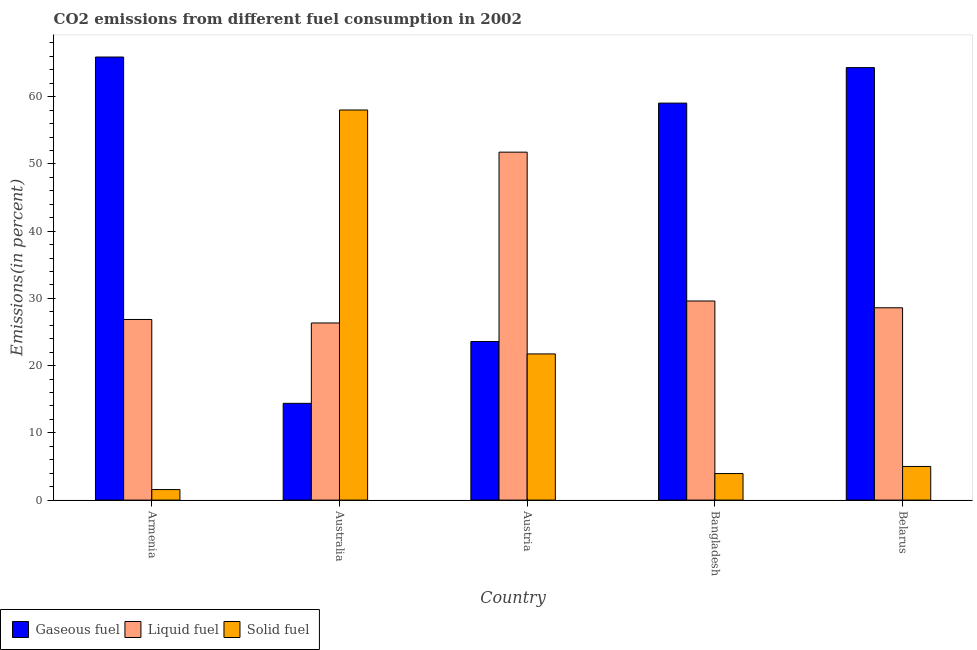How many different coloured bars are there?
Offer a terse response. 3. How many bars are there on the 1st tick from the right?
Offer a very short reply. 3. What is the percentage of liquid fuel emission in Armenia?
Ensure brevity in your answer.  26.87. Across all countries, what is the maximum percentage of gaseous fuel emission?
Ensure brevity in your answer.  65.9. Across all countries, what is the minimum percentage of gaseous fuel emission?
Your answer should be compact. 14.39. In which country was the percentage of liquid fuel emission maximum?
Your response must be concise. Austria. What is the total percentage of solid fuel emission in the graph?
Offer a terse response. 90.29. What is the difference between the percentage of liquid fuel emission in Armenia and that in Australia?
Offer a terse response. 0.52. What is the difference between the percentage of liquid fuel emission in Australia and the percentage of gaseous fuel emission in Bangladesh?
Your response must be concise. -32.7. What is the average percentage of solid fuel emission per country?
Provide a short and direct response. 18.06. What is the difference between the percentage of liquid fuel emission and percentage of solid fuel emission in Armenia?
Make the answer very short. 25.3. In how many countries, is the percentage of liquid fuel emission greater than 20 %?
Provide a succinct answer. 5. What is the ratio of the percentage of solid fuel emission in Australia to that in Austria?
Your response must be concise. 2.67. Is the percentage of solid fuel emission in Armenia less than that in Belarus?
Your answer should be compact. Yes. What is the difference between the highest and the second highest percentage of gaseous fuel emission?
Give a very brief answer. 1.57. What is the difference between the highest and the lowest percentage of solid fuel emission?
Offer a terse response. 56.46. What does the 3rd bar from the left in Austria represents?
Ensure brevity in your answer.  Solid fuel. What does the 1st bar from the right in Australia represents?
Keep it short and to the point. Solid fuel. Is it the case that in every country, the sum of the percentage of gaseous fuel emission and percentage of liquid fuel emission is greater than the percentage of solid fuel emission?
Offer a terse response. No. How many bars are there?
Your response must be concise. 15. Are all the bars in the graph horizontal?
Offer a terse response. No. What is the difference between two consecutive major ticks on the Y-axis?
Provide a succinct answer. 10. Are the values on the major ticks of Y-axis written in scientific E-notation?
Your response must be concise. No. Does the graph contain any zero values?
Make the answer very short. No. Does the graph contain grids?
Give a very brief answer. No. Where does the legend appear in the graph?
Ensure brevity in your answer.  Bottom left. How are the legend labels stacked?
Your response must be concise. Horizontal. What is the title of the graph?
Offer a very short reply. CO2 emissions from different fuel consumption in 2002. Does "Ages 20-60" appear as one of the legend labels in the graph?
Keep it short and to the point. No. What is the label or title of the Y-axis?
Give a very brief answer. Emissions(in percent). What is the Emissions(in percent) of Gaseous fuel in Armenia?
Provide a short and direct response. 65.9. What is the Emissions(in percent) in Liquid fuel in Armenia?
Your response must be concise. 26.87. What is the Emissions(in percent) in Solid fuel in Armenia?
Your response must be concise. 1.57. What is the Emissions(in percent) in Gaseous fuel in Australia?
Make the answer very short. 14.39. What is the Emissions(in percent) of Liquid fuel in Australia?
Provide a succinct answer. 26.35. What is the Emissions(in percent) of Solid fuel in Australia?
Offer a very short reply. 58.03. What is the Emissions(in percent) in Gaseous fuel in Austria?
Offer a terse response. 23.59. What is the Emissions(in percent) of Liquid fuel in Austria?
Make the answer very short. 51.75. What is the Emissions(in percent) in Solid fuel in Austria?
Provide a succinct answer. 21.74. What is the Emissions(in percent) of Gaseous fuel in Bangladesh?
Make the answer very short. 59.05. What is the Emissions(in percent) in Liquid fuel in Bangladesh?
Make the answer very short. 29.61. What is the Emissions(in percent) of Solid fuel in Bangladesh?
Your response must be concise. 3.95. What is the Emissions(in percent) in Gaseous fuel in Belarus?
Provide a short and direct response. 64.33. What is the Emissions(in percent) in Liquid fuel in Belarus?
Keep it short and to the point. 28.61. What is the Emissions(in percent) in Solid fuel in Belarus?
Provide a short and direct response. 5. Across all countries, what is the maximum Emissions(in percent) in Gaseous fuel?
Your answer should be very brief. 65.9. Across all countries, what is the maximum Emissions(in percent) in Liquid fuel?
Offer a very short reply. 51.75. Across all countries, what is the maximum Emissions(in percent) in Solid fuel?
Your answer should be very brief. 58.03. Across all countries, what is the minimum Emissions(in percent) in Gaseous fuel?
Give a very brief answer. 14.39. Across all countries, what is the minimum Emissions(in percent) of Liquid fuel?
Provide a succinct answer. 26.35. Across all countries, what is the minimum Emissions(in percent) of Solid fuel?
Give a very brief answer. 1.57. What is the total Emissions(in percent) of Gaseous fuel in the graph?
Provide a short and direct response. 227.26. What is the total Emissions(in percent) of Liquid fuel in the graph?
Offer a terse response. 163.19. What is the total Emissions(in percent) in Solid fuel in the graph?
Keep it short and to the point. 90.29. What is the difference between the Emissions(in percent) of Gaseous fuel in Armenia and that in Australia?
Your answer should be compact. 51.51. What is the difference between the Emissions(in percent) of Liquid fuel in Armenia and that in Australia?
Your answer should be compact. 0.52. What is the difference between the Emissions(in percent) in Solid fuel in Armenia and that in Australia?
Your answer should be compact. -56.46. What is the difference between the Emissions(in percent) of Gaseous fuel in Armenia and that in Austria?
Give a very brief answer. 42.32. What is the difference between the Emissions(in percent) in Liquid fuel in Armenia and that in Austria?
Keep it short and to the point. -24.89. What is the difference between the Emissions(in percent) in Solid fuel in Armenia and that in Austria?
Make the answer very short. -20.17. What is the difference between the Emissions(in percent) in Gaseous fuel in Armenia and that in Bangladesh?
Give a very brief answer. 6.85. What is the difference between the Emissions(in percent) of Liquid fuel in Armenia and that in Bangladesh?
Give a very brief answer. -2.75. What is the difference between the Emissions(in percent) of Solid fuel in Armenia and that in Bangladesh?
Provide a succinct answer. -2.38. What is the difference between the Emissions(in percent) in Gaseous fuel in Armenia and that in Belarus?
Your answer should be compact. 1.57. What is the difference between the Emissions(in percent) in Liquid fuel in Armenia and that in Belarus?
Make the answer very short. -1.74. What is the difference between the Emissions(in percent) of Solid fuel in Armenia and that in Belarus?
Your answer should be very brief. -3.44. What is the difference between the Emissions(in percent) in Gaseous fuel in Australia and that in Austria?
Provide a short and direct response. -9.19. What is the difference between the Emissions(in percent) of Liquid fuel in Australia and that in Austria?
Offer a very short reply. -25.41. What is the difference between the Emissions(in percent) of Solid fuel in Australia and that in Austria?
Provide a short and direct response. 36.28. What is the difference between the Emissions(in percent) in Gaseous fuel in Australia and that in Bangladesh?
Ensure brevity in your answer.  -44.66. What is the difference between the Emissions(in percent) in Liquid fuel in Australia and that in Bangladesh?
Offer a terse response. -3.27. What is the difference between the Emissions(in percent) in Solid fuel in Australia and that in Bangladesh?
Your answer should be very brief. 54.08. What is the difference between the Emissions(in percent) in Gaseous fuel in Australia and that in Belarus?
Your answer should be very brief. -49.94. What is the difference between the Emissions(in percent) in Liquid fuel in Australia and that in Belarus?
Make the answer very short. -2.26. What is the difference between the Emissions(in percent) of Solid fuel in Australia and that in Belarus?
Offer a terse response. 53.02. What is the difference between the Emissions(in percent) of Gaseous fuel in Austria and that in Bangladesh?
Offer a very short reply. -35.47. What is the difference between the Emissions(in percent) in Liquid fuel in Austria and that in Bangladesh?
Your answer should be compact. 22.14. What is the difference between the Emissions(in percent) of Solid fuel in Austria and that in Bangladesh?
Your response must be concise. 17.79. What is the difference between the Emissions(in percent) in Gaseous fuel in Austria and that in Belarus?
Your answer should be very brief. -40.75. What is the difference between the Emissions(in percent) of Liquid fuel in Austria and that in Belarus?
Provide a short and direct response. 23.15. What is the difference between the Emissions(in percent) in Solid fuel in Austria and that in Belarus?
Your answer should be compact. 16.74. What is the difference between the Emissions(in percent) in Gaseous fuel in Bangladesh and that in Belarus?
Your response must be concise. -5.28. What is the difference between the Emissions(in percent) of Liquid fuel in Bangladesh and that in Belarus?
Provide a short and direct response. 1.01. What is the difference between the Emissions(in percent) of Solid fuel in Bangladesh and that in Belarus?
Your answer should be very brief. -1.06. What is the difference between the Emissions(in percent) in Gaseous fuel in Armenia and the Emissions(in percent) in Liquid fuel in Australia?
Offer a very short reply. 39.56. What is the difference between the Emissions(in percent) in Gaseous fuel in Armenia and the Emissions(in percent) in Solid fuel in Australia?
Offer a very short reply. 7.88. What is the difference between the Emissions(in percent) in Liquid fuel in Armenia and the Emissions(in percent) in Solid fuel in Australia?
Provide a short and direct response. -31.16. What is the difference between the Emissions(in percent) in Gaseous fuel in Armenia and the Emissions(in percent) in Liquid fuel in Austria?
Your answer should be compact. 14.15. What is the difference between the Emissions(in percent) of Gaseous fuel in Armenia and the Emissions(in percent) of Solid fuel in Austria?
Your answer should be very brief. 44.16. What is the difference between the Emissions(in percent) in Liquid fuel in Armenia and the Emissions(in percent) in Solid fuel in Austria?
Provide a succinct answer. 5.13. What is the difference between the Emissions(in percent) in Gaseous fuel in Armenia and the Emissions(in percent) in Liquid fuel in Bangladesh?
Your response must be concise. 36.29. What is the difference between the Emissions(in percent) in Gaseous fuel in Armenia and the Emissions(in percent) in Solid fuel in Bangladesh?
Your response must be concise. 61.95. What is the difference between the Emissions(in percent) of Liquid fuel in Armenia and the Emissions(in percent) of Solid fuel in Bangladesh?
Offer a terse response. 22.92. What is the difference between the Emissions(in percent) in Gaseous fuel in Armenia and the Emissions(in percent) in Liquid fuel in Belarus?
Keep it short and to the point. 37.3. What is the difference between the Emissions(in percent) in Gaseous fuel in Armenia and the Emissions(in percent) in Solid fuel in Belarus?
Provide a succinct answer. 60.9. What is the difference between the Emissions(in percent) in Liquid fuel in Armenia and the Emissions(in percent) in Solid fuel in Belarus?
Your response must be concise. 21.86. What is the difference between the Emissions(in percent) in Gaseous fuel in Australia and the Emissions(in percent) in Liquid fuel in Austria?
Your answer should be compact. -37.36. What is the difference between the Emissions(in percent) in Gaseous fuel in Australia and the Emissions(in percent) in Solid fuel in Austria?
Offer a very short reply. -7.35. What is the difference between the Emissions(in percent) in Liquid fuel in Australia and the Emissions(in percent) in Solid fuel in Austria?
Your answer should be very brief. 4.61. What is the difference between the Emissions(in percent) in Gaseous fuel in Australia and the Emissions(in percent) in Liquid fuel in Bangladesh?
Ensure brevity in your answer.  -15.22. What is the difference between the Emissions(in percent) of Gaseous fuel in Australia and the Emissions(in percent) of Solid fuel in Bangladesh?
Keep it short and to the point. 10.44. What is the difference between the Emissions(in percent) in Liquid fuel in Australia and the Emissions(in percent) in Solid fuel in Bangladesh?
Your response must be concise. 22.4. What is the difference between the Emissions(in percent) in Gaseous fuel in Australia and the Emissions(in percent) in Liquid fuel in Belarus?
Keep it short and to the point. -14.21. What is the difference between the Emissions(in percent) in Gaseous fuel in Australia and the Emissions(in percent) in Solid fuel in Belarus?
Offer a terse response. 9.39. What is the difference between the Emissions(in percent) in Liquid fuel in Australia and the Emissions(in percent) in Solid fuel in Belarus?
Offer a terse response. 21.34. What is the difference between the Emissions(in percent) of Gaseous fuel in Austria and the Emissions(in percent) of Liquid fuel in Bangladesh?
Provide a short and direct response. -6.03. What is the difference between the Emissions(in percent) in Gaseous fuel in Austria and the Emissions(in percent) in Solid fuel in Bangladesh?
Your answer should be compact. 19.64. What is the difference between the Emissions(in percent) of Liquid fuel in Austria and the Emissions(in percent) of Solid fuel in Bangladesh?
Provide a succinct answer. 47.81. What is the difference between the Emissions(in percent) in Gaseous fuel in Austria and the Emissions(in percent) in Liquid fuel in Belarus?
Ensure brevity in your answer.  -5.02. What is the difference between the Emissions(in percent) of Gaseous fuel in Austria and the Emissions(in percent) of Solid fuel in Belarus?
Your answer should be very brief. 18.58. What is the difference between the Emissions(in percent) in Liquid fuel in Austria and the Emissions(in percent) in Solid fuel in Belarus?
Make the answer very short. 46.75. What is the difference between the Emissions(in percent) in Gaseous fuel in Bangladesh and the Emissions(in percent) in Liquid fuel in Belarus?
Your answer should be compact. 30.44. What is the difference between the Emissions(in percent) of Gaseous fuel in Bangladesh and the Emissions(in percent) of Solid fuel in Belarus?
Provide a short and direct response. 54.05. What is the difference between the Emissions(in percent) in Liquid fuel in Bangladesh and the Emissions(in percent) in Solid fuel in Belarus?
Your response must be concise. 24.61. What is the average Emissions(in percent) in Gaseous fuel per country?
Your response must be concise. 45.45. What is the average Emissions(in percent) in Liquid fuel per country?
Offer a terse response. 32.64. What is the average Emissions(in percent) of Solid fuel per country?
Keep it short and to the point. 18.06. What is the difference between the Emissions(in percent) in Gaseous fuel and Emissions(in percent) in Liquid fuel in Armenia?
Give a very brief answer. 39.04. What is the difference between the Emissions(in percent) of Gaseous fuel and Emissions(in percent) of Solid fuel in Armenia?
Ensure brevity in your answer.  64.34. What is the difference between the Emissions(in percent) in Liquid fuel and Emissions(in percent) in Solid fuel in Armenia?
Ensure brevity in your answer.  25.3. What is the difference between the Emissions(in percent) in Gaseous fuel and Emissions(in percent) in Liquid fuel in Australia?
Keep it short and to the point. -11.95. What is the difference between the Emissions(in percent) of Gaseous fuel and Emissions(in percent) of Solid fuel in Australia?
Make the answer very short. -43.63. What is the difference between the Emissions(in percent) in Liquid fuel and Emissions(in percent) in Solid fuel in Australia?
Your response must be concise. -31.68. What is the difference between the Emissions(in percent) of Gaseous fuel and Emissions(in percent) of Liquid fuel in Austria?
Your answer should be very brief. -28.17. What is the difference between the Emissions(in percent) in Gaseous fuel and Emissions(in percent) in Solid fuel in Austria?
Provide a short and direct response. 1.85. What is the difference between the Emissions(in percent) in Liquid fuel and Emissions(in percent) in Solid fuel in Austria?
Give a very brief answer. 30.01. What is the difference between the Emissions(in percent) of Gaseous fuel and Emissions(in percent) of Liquid fuel in Bangladesh?
Provide a succinct answer. 29.44. What is the difference between the Emissions(in percent) in Gaseous fuel and Emissions(in percent) in Solid fuel in Bangladesh?
Your answer should be compact. 55.1. What is the difference between the Emissions(in percent) in Liquid fuel and Emissions(in percent) in Solid fuel in Bangladesh?
Offer a very short reply. 25.66. What is the difference between the Emissions(in percent) of Gaseous fuel and Emissions(in percent) of Liquid fuel in Belarus?
Provide a succinct answer. 35.72. What is the difference between the Emissions(in percent) of Gaseous fuel and Emissions(in percent) of Solid fuel in Belarus?
Your response must be concise. 59.33. What is the difference between the Emissions(in percent) in Liquid fuel and Emissions(in percent) in Solid fuel in Belarus?
Your answer should be compact. 23.6. What is the ratio of the Emissions(in percent) in Gaseous fuel in Armenia to that in Australia?
Make the answer very short. 4.58. What is the ratio of the Emissions(in percent) in Liquid fuel in Armenia to that in Australia?
Your answer should be compact. 1.02. What is the ratio of the Emissions(in percent) of Solid fuel in Armenia to that in Australia?
Offer a terse response. 0.03. What is the ratio of the Emissions(in percent) in Gaseous fuel in Armenia to that in Austria?
Offer a terse response. 2.79. What is the ratio of the Emissions(in percent) in Liquid fuel in Armenia to that in Austria?
Your answer should be very brief. 0.52. What is the ratio of the Emissions(in percent) in Solid fuel in Armenia to that in Austria?
Your response must be concise. 0.07. What is the ratio of the Emissions(in percent) in Gaseous fuel in Armenia to that in Bangladesh?
Offer a terse response. 1.12. What is the ratio of the Emissions(in percent) in Liquid fuel in Armenia to that in Bangladesh?
Your answer should be very brief. 0.91. What is the ratio of the Emissions(in percent) of Solid fuel in Armenia to that in Bangladesh?
Your answer should be very brief. 0.4. What is the ratio of the Emissions(in percent) of Gaseous fuel in Armenia to that in Belarus?
Your answer should be compact. 1.02. What is the ratio of the Emissions(in percent) of Liquid fuel in Armenia to that in Belarus?
Your answer should be compact. 0.94. What is the ratio of the Emissions(in percent) in Solid fuel in Armenia to that in Belarus?
Offer a terse response. 0.31. What is the ratio of the Emissions(in percent) in Gaseous fuel in Australia to that in Austria?
Provide a short and direct response. 0.61. What is the ratio of the Emissions(in percent) of Liquid fuel in Australia to that in Austria?
Your answer should be compact. 0.51. What is the ratio of the Emissions(in percent) of Solid fuel in Australia to that in Austria?
Keep it short and to the point. 2.67. What is the ratio of the Emissions(in percent) in Gaseous fuel in Australia to that in Bangladesh?
Provide a short and direct response. 0.24. What is the ratio of the Emissions(in percent) of Liquid fuel in Australia to that in Bangladesh?
Offer a terse response. 0.89. What is the ratio of the Emissions(in percent) in Solid fuel in Australia to that in Bangladesh?
Provide a short and direct response. 14.69. What is the ratio of the Emissions(in percent) of Gaseous fuel in Australia to that in Belarus?
Ensure brevity in your answer.  0.22. What is the ratio of the Emissions(in percent) of Liquid fuel in Australia to that in Belarus?
Provide a short and direct response. 0.92. What is the ratio of the Emissions(in percent) in Solid fuel in Australia to that in Belarus?
Make the answer very short. 11.59. What is the ratio of the Emissions(in percent) of Gaseous fuel in Austria to that in Bangladesh?
Make the answer very short. 0.4. What is the ratio of the Emissions(in percent) of Liquid fuel in Austria to that in Bangladesh?
Make the answer very short. 1.75. What is the ratio of the Emissions(in percent) in Solid fuel in Austria to that in Bangladesh?
Your response must be concise. 5.51. What is the ratio of the Emissions(in percent) in Gaseous fuel in Austria to that in Belarus?
Provide a succinct answer. 0.37. What is the ratio of the Emissions(in percent) in Liquid fuel in Austria to that in Belarus?
Your answer should be compact. 1.81. What is the ratio of the Emissions(in percent) in Solid fuel in Austria to that in Belarus?
Your answer should be compact. 4.34. What is the ratio of the Emissions(in percent) of Gaseous fuel in Bangladesh to that in Belarus?
Ensure brevity in your answer.  0.92. What is the ratio of the Emissions(in percent) of Liquid fuel in Bangladesh to that in Belarus?
Offer a terse response. 1.04. What is the ratio of the Emissions(in percent) in Solid fuel in Bangladesh to that in Belarus?
Offer a very short reply. 0.79. What is the difference between the highest and the second highest Emissions(in percent) in Gaseous fuel?
Ensure brevity in your answer.  1.57. What is the difference between the highest and the second highest Emissions(in percent) in Liquid fuel?
Provide a succinct answer. 22.14. What is the difference between the highest and the second highest Emissions(in percent) of Solid fuel?
Keep it short and to the point. 36.28. What is the difference between the highest and the lowest Emissions(in percent) of Gaseous fuel?
Give a very brief answer. 51.51. What is the difference between the highest and the lowest Emissions(in percent) in Liquid fuel?
Your answer should be very brief. 25.41. What is the difference between the highest and the lowest Emissions(in percent) in Solid fuel?
Make the answer very short. 56.46. 